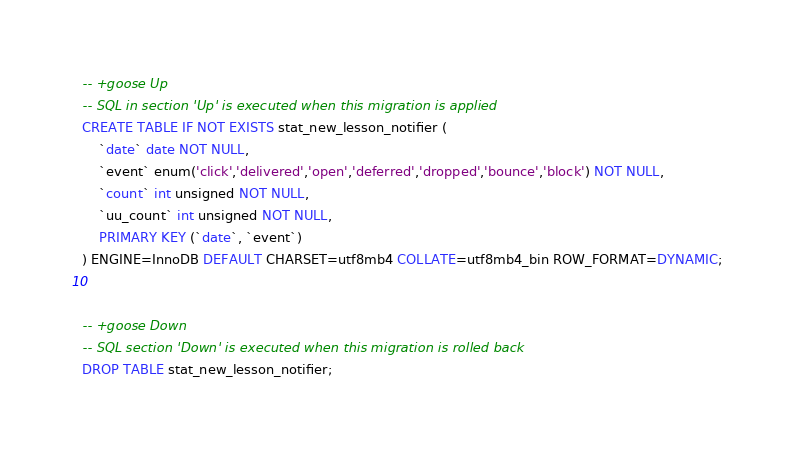<code> <loc_0><loc_0><loc_500><loc_500><_SQL_>-- +goose Up
-- SQL in section 'Up' is executed when this migration is applied
CREATE TABLE IF NOT EXISTS stat_new_lesson_notifier (
    `date` date NOT NULL,
    `event` enum('click','delivered','open','deferred','dropped','bounce','block') NOT NULL,
    `count` int unsigned NOT NULL,
    `uu_count` int unsigned NOT NULL,
    PRIMARY KEY (`date`, `event`)
) ENGINE=InnoDB DEFAULT CHARSET=utf8mb4 COLLATE=utf8mb4_bin ROW_FORMAT=DYNAMIC;


-- +goose Down
-- SQL section 'Down' is executed when this migration is rolled back
DROP TABLE stat_new_lesson_notifier;
</code> 